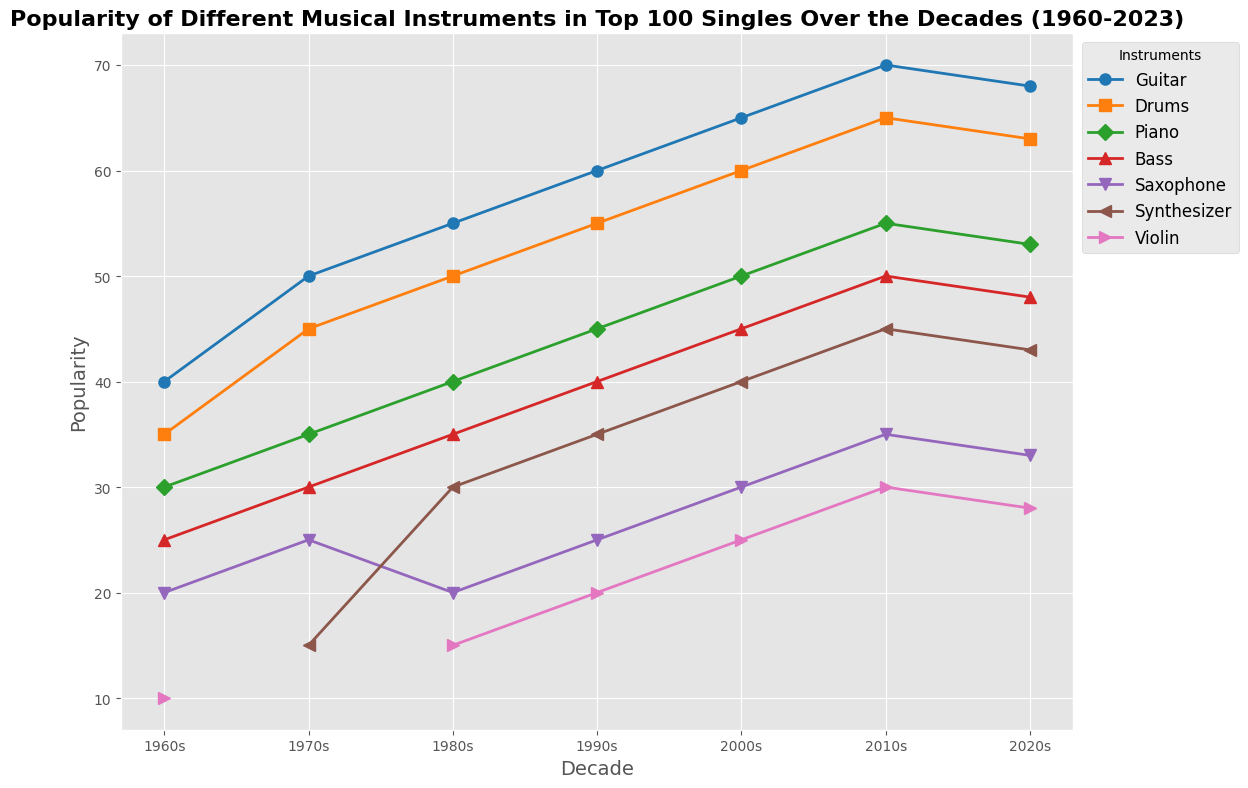Which instrument saw the highest popularity in the 1960s? To identify the highest popularity, look at the 1960s data points across all instruments. The Guitar has the highest popularity score of 40.
Answer: Guitar How has the popularity of the Synthesizer changed from the 1970s to the 2020s? Look at the data points for the Synthesizer from the 1970s (15) and the 2020s (43). The change in popularity is 43 - 15 = 28.
Answer: Increased by 28 Which decade saw the peak popularity for the Piano? Compare the popularity of the Piano across all decades. The highest value for the Piano is in the 2010s, with a popularity of 55.
Answer: 2010s What is the difference in popularity between the Bass and the Synthesizer in the 2000s? Find the popularity of the Bass (45) and the Synthesizer (40) in the 2000s. Calculate the difference: 45 - 40 = 5.
Answer: 5 Which instrument had the least increase in popularity from the 1960s to the 2020s? Calculate the increase for each instrument from the 1960s to the 2020s. Guitar: 68 - 40 = 28, Drums: 63 - 35 = 28, Piano: 53 - 30 = 23, Bass: 48 - 25 = 23, Saxophone: 33 - 20 = 13, Violin: 28 - 10 = 18. Synthesizer is not applicable as it started in the 1970s. The Saxophone saw the least increase (13).
Answer: Saxophone Which instrument consistently increased its popularity every decade? Examine the data for all instruments across each decade. The Guitar consistently increases in popularity in every decade (40, 50, 55, 60, 65, 70, 68).
Answer: Guitar What is the average popularity of the Drums in the 2010s and 2020s? Add the popularity of the Drums in the 2010s (65) and the 2020s (63), then divide by 2: (65 + 63) / 2 = 64.
Answer: 64 Which instrument saw a decline in popularity from the 2010s to the 2020s? Compare the popularity of each instrument between the 2010s and 2020s. The Guitar (70 to 68) and Drums (65 to 63) both saw declines.
Answer: Guitar and Drums 